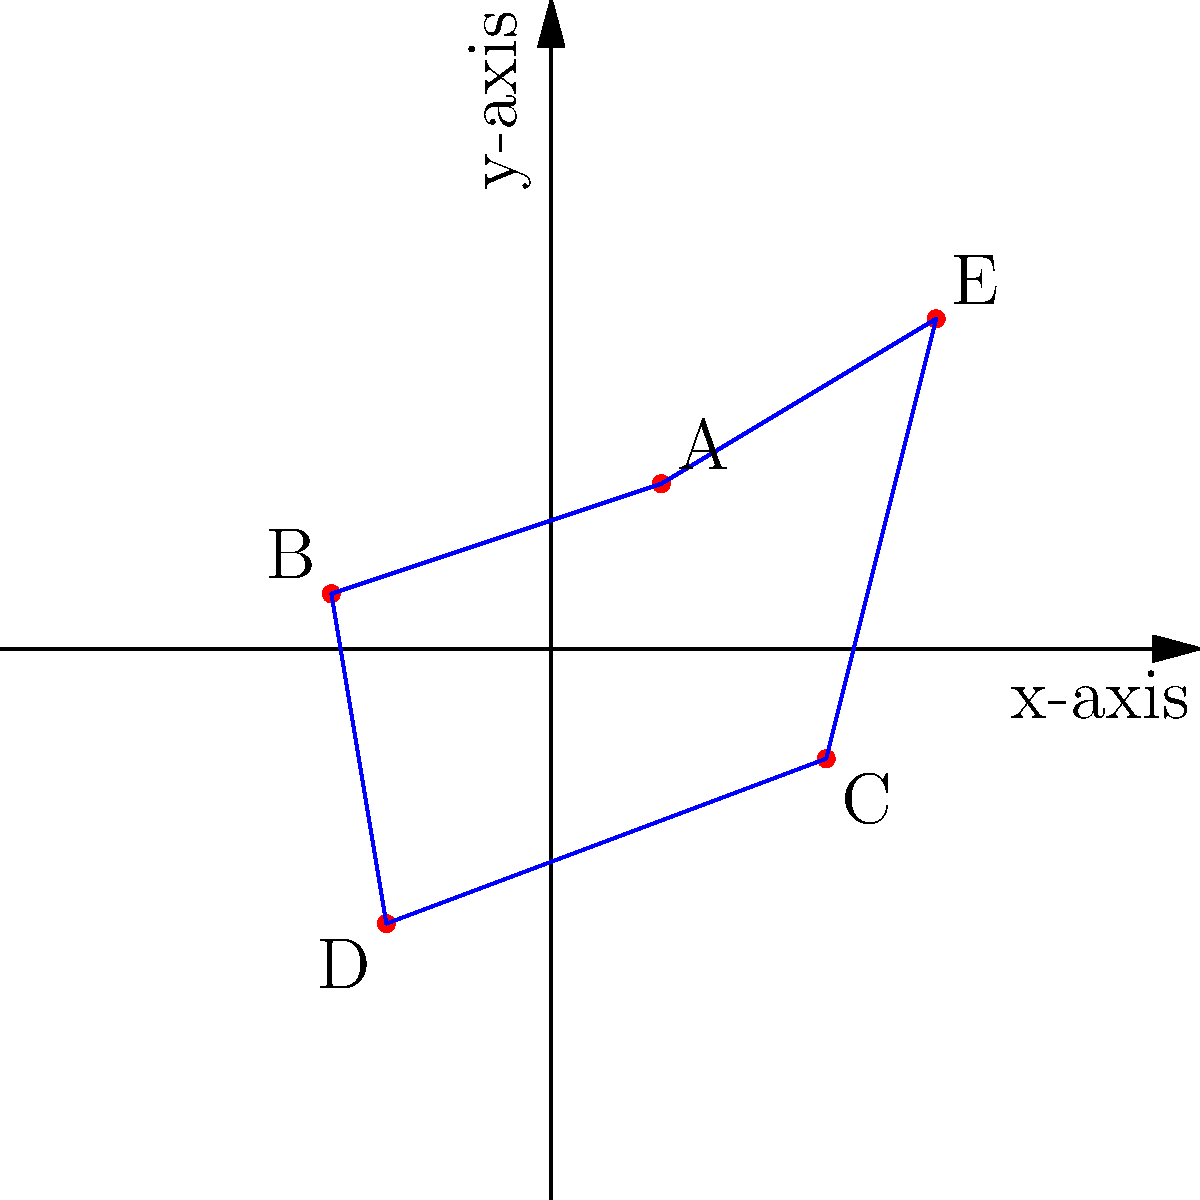In a study on food deserts in a city, researchers plotted the locations of areas with limited access to fresh food on a coordinate plane. The points A(2,3), B(-4,1), C(5,-2), D(-3,-5), and E(7,6) represent these food desert locations. To analyze the distribution, they want to calculate the area of the region encompassing all these points. What is the area of the convex hull formed by these points? To solve this problem, we'll follow these steps:

1) Identify the vertices of the convex hull:
   The convex hull includes all the given points: A(2,3), B(-4,1), C(5,-2), D(-3,-5), and E(7,6).

2) Use the Shoelace formula to calculate the area:
   Area = $\frac{1}{2}|\sum_{i=1}^{n-1} (x_iy_{i+1} - x_{i+1}y_i) + (x_ny_1 - x_1y_n)|$

3) Apply the formula:
   Area = $\frac{1}{2}|[(2 \cdot 1 - (-4) \cdot 3) + ((-4) \cdot (-2) - 5 \cdot 1) + (5 \cdot (-5) - (-3) \cdot (-2)) + ((-3) \cdot 6 - 7 \cdot (-5)) + (7 \cdot 3 - 2 \cdot 6)]|$

4) Calculate each term:
   $= \frac{1}{2}|[-14 + 3 - 25 - 18 + 53 + 9]|$

5) Sum the terms:
   $= \frac{1}{2}|8|$

6) Simplify:
   $= 4$

Therefore, the area of the convex hull is 4 square units.
Answer: 4 square units 